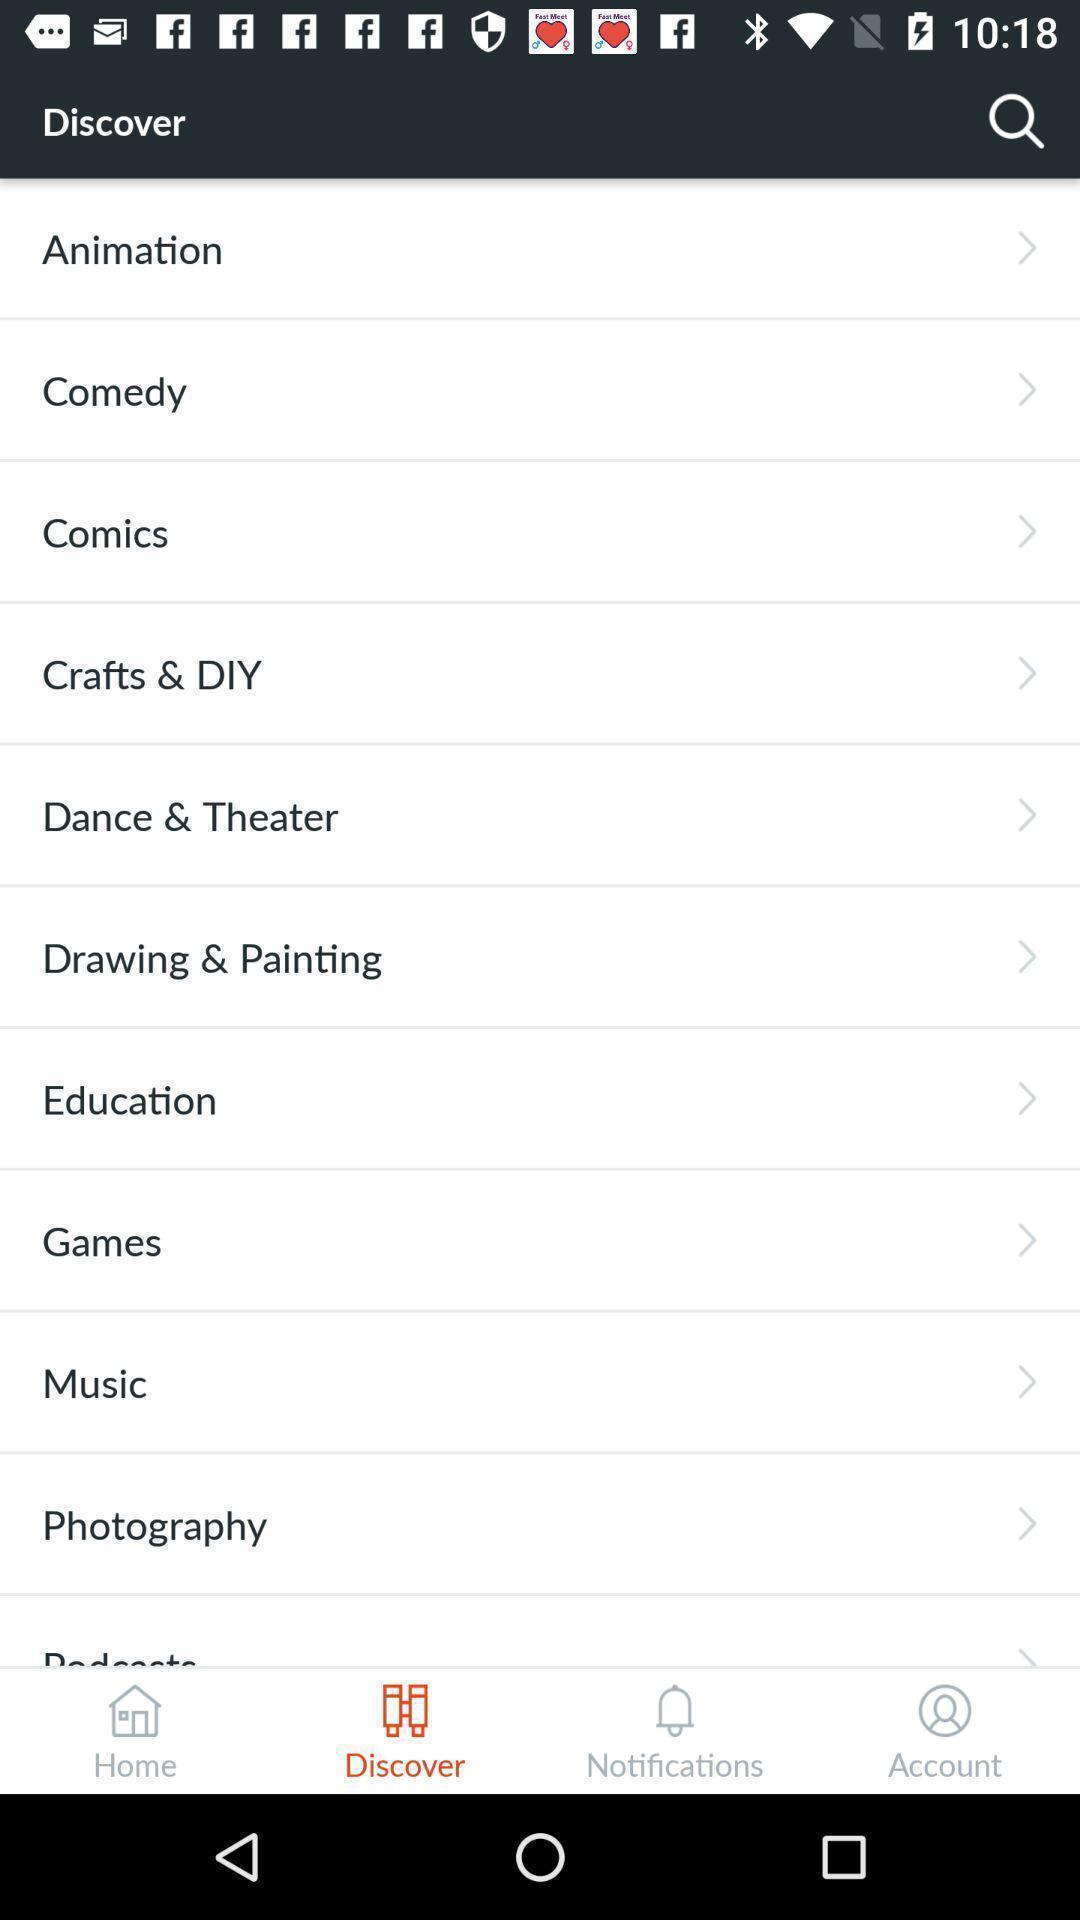Describe the key features of this screenshot. Page showing search icon to find different interest. 